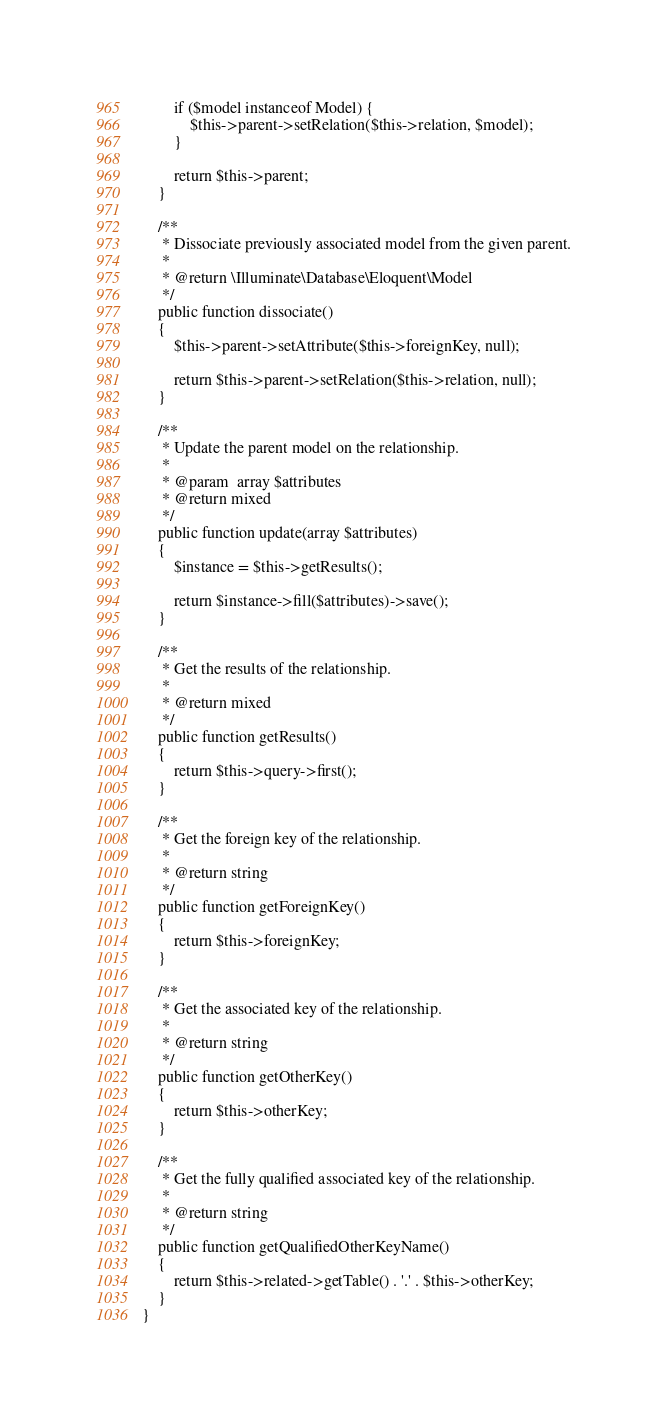Convert code to text. <code><loc_0><loc_0><loc_500><loc_500><_PHP_>        if ($model instanceof Model) {
            $this->parent->setRelation($this->relation, $model);
        }

        return $this->parent;
    }

    /**
     * Dissociate previously associated model from the given parent.
     *
     * @return \Illuminate\Database\Eloquent\Model
     */
    public function dissociate()
    {
        $this->parent->setAttribute($this->foreignKey, null);

        return $this->parent->setRelation($this->relation, null);
    }

    /**
     * Update the parent model on the relationship.
     *
     * @param  array $attributes
     * @return mixed
     */
    public function update(array $attributes)
    {
        $instance = $this->getResults();

        return $instance->fill($attributes)->save();
    }

    /**
     * Get the results of the relationship.
     *
     * @return mixed
     */
    public function getResults()
    {
        return $this->query->first();
    }

    /**
     * Get the foreign key of the relationship.
     *
     * @return string
     */
    public function getForeignKey()
    {
        return $this->foreignKey;
    }

    /**
     * Get the associated key of the relationship.
     *
     * @return string
     */
    public function getOtherKey()
    {
        return $this->otherKey;
    }

    /**
     * Get the fully qualified associated key of the relationship.
     *
     * @return string
     */
    public function getQualifiedOtherKeyName()
    {
        return $this->related->getTable() . '.' . $this->otherKey;
    }
}
</code> 